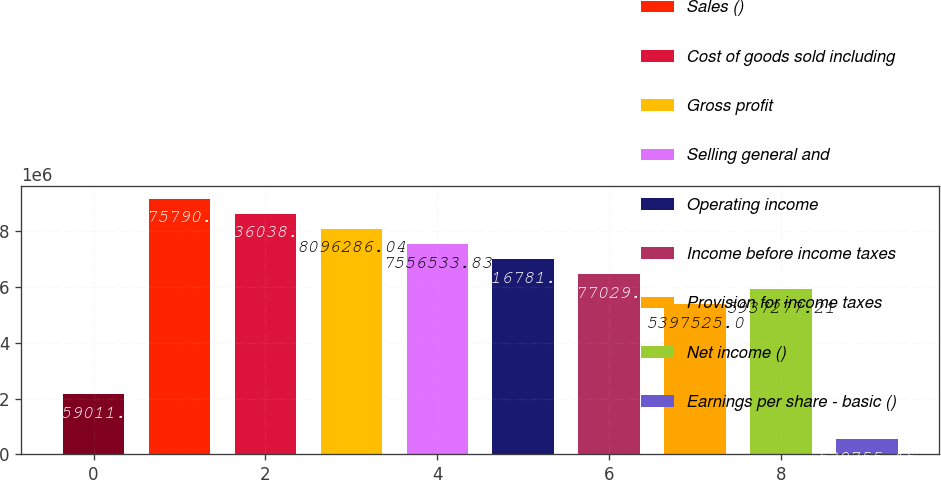Convert chart to OTSL. <chart><loc_0><loc_0><loc_500><loc_500><bar_chart><fcel>Years ended December 31<fcel>Sales ()<fcel>Cost of goods sold including<fcel>Gross profit<fcel>Selling general and<fcel>Operating income<fcel>Income before income taxes<fcel>Provision for income taxes<fcel>Net income ()<fcel>Earnings per share - basic ()<nl><fcel>2.15901e+06<fcel>9.17579e+06<fcel>8.63604e+06<fcel>8.09629e+06<fcel>7.55653e+06<fcel>7.01678e+06<fcel>6.47703e+06<fcel>5.39752e+06<fcel>5.93728e+06<fcel>539755<nl></chart> 